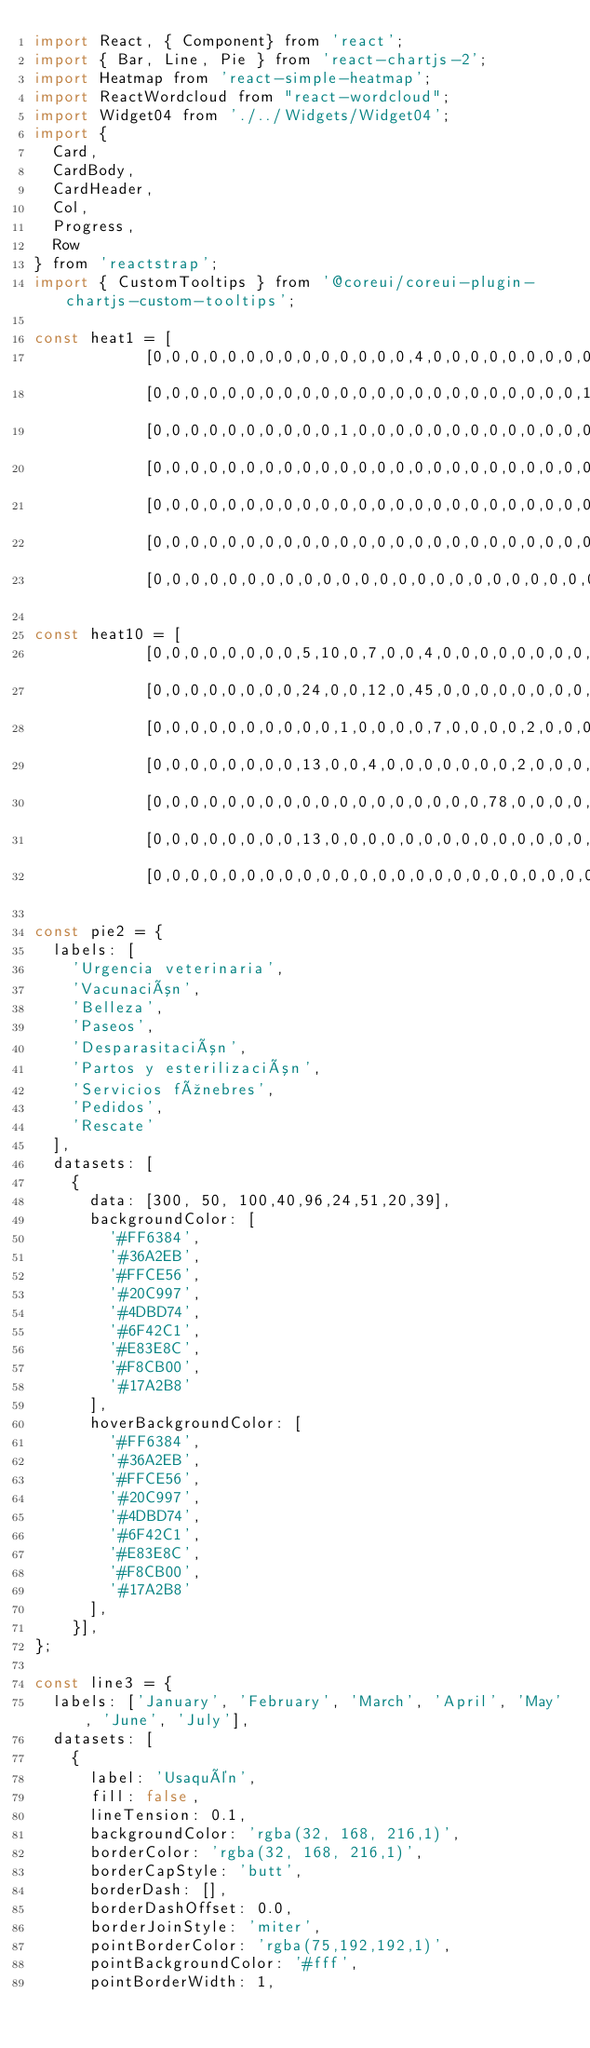Convert code to text. <code><loc_0><loc_0><loc_500><loc_500><_JavaScript_>import React, { Component} from 'react';
import { Bar, Line, Pie } from 'react-chartjs-2';
import Heatmap from 'react-simple-heatmap';
import ReactWordcloud from "react-wordcloud";
import Widget04 from './../Widgets/Widget04';
import {
  Card,
  CardBody,
  CardHeader,
  Col,
  Progress,
  Row
} from 'reactstrap';
import { CustomTooltips } from '@coreui/coreui-plugin-chartjs-custom-tooltips';

const heat1 = [
            [0,0,0,0,0,0,0,0,0,0,0,0,0,0,4,0,0,0,0,0,0,0,0,0],
            [0,0,0,0,0,0,0,0,0,0,0,0,0,0,0,0,0,0,0,0,0,0,0,1],
            [0,0,0,0,0,0,0,0,0,0,1,0,0,0,0,0,0,0,0,0,0,0,0,0],
            [0,0,0,0,0,0,0,0,0,0,0,0,0,0,0,0,0,0,0,0,0,0,0,0],
            [0,0,0,0,0,0,0,0,0,0,0,0,0,0,0,0,0,0,0,0,0,0,0,0],
            [0,0,0,0,0,0,0,0,0,0,0,0,0,0,0,0,0,0,0,0,0,0,0,0],
            [0,0,0,0,0,0,0,0,0,0,0,0,0,0,0,0,0,0,0,0,0,0,0,0]];

const heat10 = [
            [0,0,0,0,0,0,0,0,5,10,0,7,0,0,4,0,0,0,0,0,0,0,0,0],
            [0,0,0,0,0,0,0,0,24,0,0,12,0,45,0,0,0,0,0,0,0,0,0,1],
            [0,0,0,0,0,0,0,0,0,0,1,0,0,0,0,7,0,0,0,0,2,0,0,0],
            [0,0,0,0,0,0,0,0,13,0,0,4,0,0,0,0,0,0,0,2,0,0,0,0],
            [0,0,0,0,0,0,0,0,0,0,0,0,0,0,0,0,0,0,78,0,0,0,0,0],
            [0,0,0,0,0,0,0,0,13,0,0,0,0,0,0,0,0,0,0,0,0,0,0,0],
            [0,0,0,0,0,0,0,0,0,0,0,0,0,0,0,0,0,0,0,0,0,0,0,0]]

const pie2 = {
  labels: [
    'Urgencia veterinaria',
    'Vacunación',
    'Belleza',
    'Paseos',
    'Desparasitación',
    'Partos y esterilización',
    'Servicios fúnebres',
    'Pedidos',
    'Rescate'
  ],
  datasets: [
    {
      data: [300, 50, 100,40,96,24,51,20,39],
      backgroundColor: [
        '#FF6384',
        '#36A2EB',
        '#FFCE56',
        '#20C997',
        '#4DBD74',
        '#6F42C1',
        '#E83E8C',
        '#F8CB00',
        '#17A2B8'
      ],
      hoverBackgroundColor: [
        '#FF6384',
        '#36A2EB',
        '#FFCE56',
        '#20C997',
        '#4DBD74',
        '#6F42C1',
        '#E83E8C',
        '#F8CB00',
        '#17A2B8'
      ],
    }],
};

const line3 = {
  labels: ['January', 'February', 'March', 'April', 'May', 'June', 'July'],
  datasets: [
    {
      label: 'Usaquén',
      fill: false,
      lineTension: 0.1,
      backgroundColor: 'rgba(32, 168, 216,1)',
      borderColor: 'rgba(32, 168, 216,1)',
      borderCapStyle: 'butt',
      borderDash: [],
      borderDashOffset: 0.0,
      borderJoinStyle: 'miter',
      pointBorderColor: 'rgba(75,192,192,1)',
      pointBackgroundColor: '#fff',
      pointBorderWidth: 1,</code> 